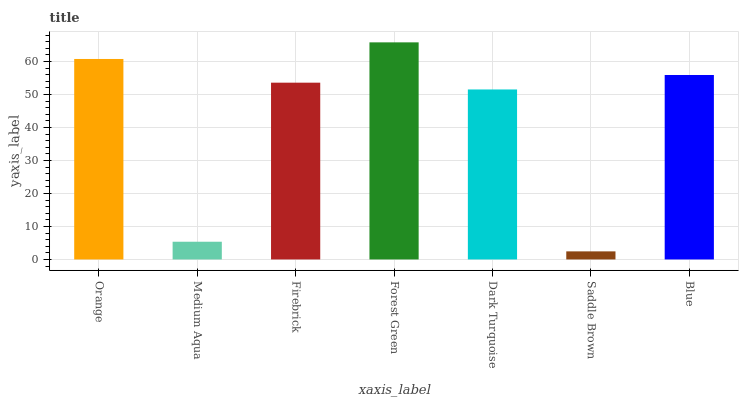Is Medium Aqua the minimum?
Answer yes or no. No. Is Medium Aqua the maximum?
Answer yes or no. No. Is Orange greater than Medium Aqua?
Answer yes or no. Yes. Is Medium Aqua less than Orange?
Answer yes or no. Yes. Is Medium Aqua greater than Orange?
Answer yes or no. No. Is Orange less than Medium Aqua?
Answer yes or no. No. Is Firebrick the high median?
Answer yes or no. Yes. Is Firebrick the low median?
Answer yes or no. Yes. Is Medium Aqua the high median?
Answer yes or no. No. Is Forest Green the low median?
Answer yes or no. No. 